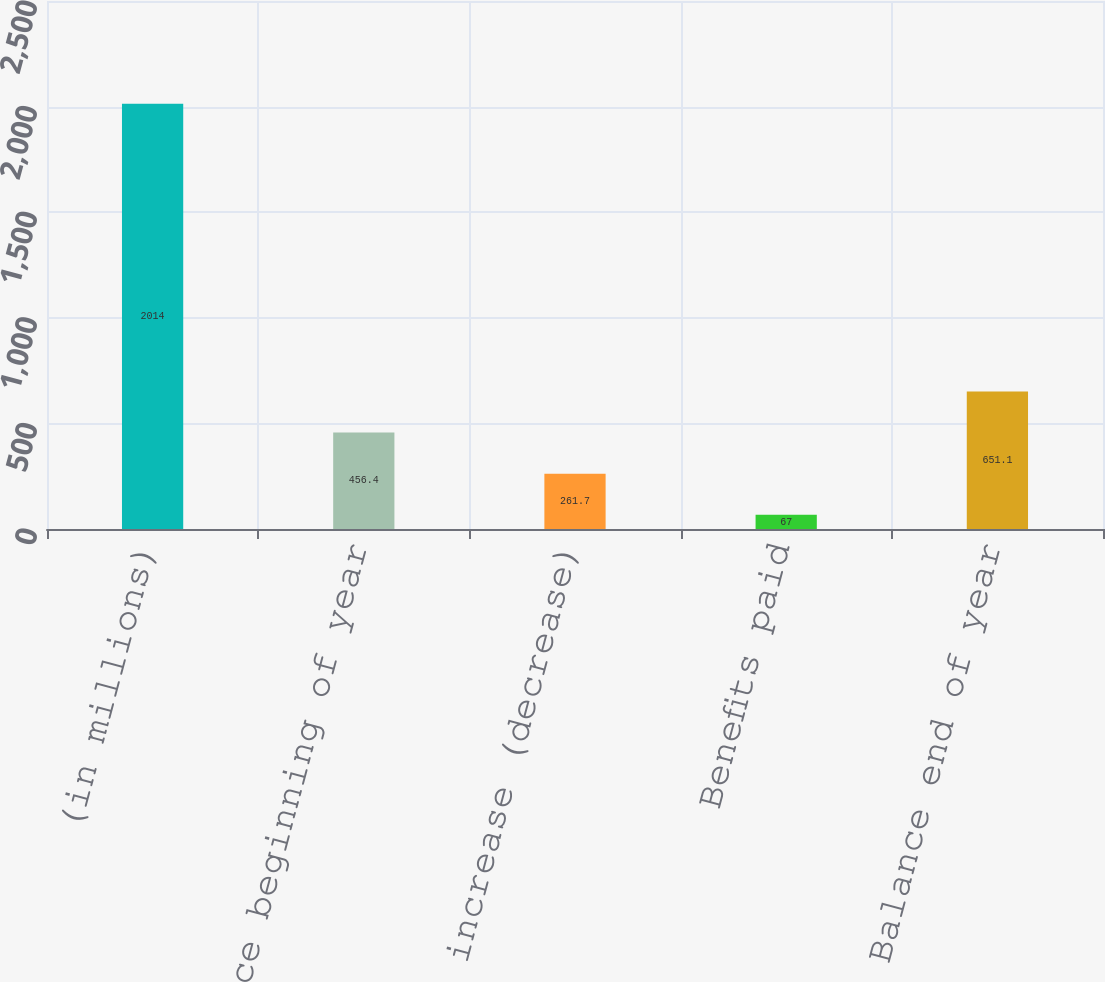Convert chart. <chart><loc_0><loc_0><loc_500><loc_500><bar_chart><fcel>(in millions)<fcel>Balance beginning of year<fcel>Reserve increase (decrease)<fcel>Benefits paid<fcel>Balance end of year<nl><fcel>2014<fcel>456.4<fcel>261.7<fcel>67<fcel>651.1<nl></chart> 